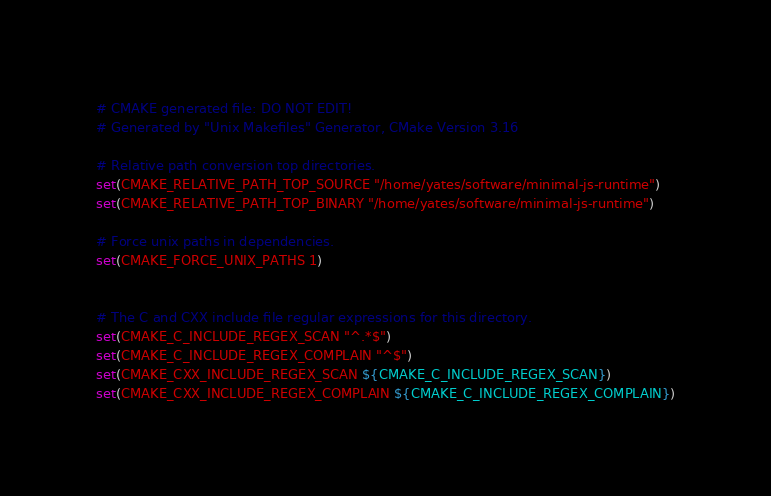<code> <loc_0><loc_0><loc_500><loc_500><_CMake_># CMAKE generated file: DO NOT EDIT!
# Generated by "Unix Makefiles" Generator, CMake Version 3.16

# Relative path conversion top directories.
set(CMAKE_RELATIVE_PATH_TOP_SOURCE "/home/yates/software/minimal-js-runtime")
set(CMAKE_RELATIVE_PATH_TOP_BINARY "/home/yates/software/minimal-js-runtime")

# Force unix paths in dependencies.
set(CMAKE_FORCE_UNIX_PATHS 1)


# The C and CXX include file regular expressions for this directory.
set(CMAKE_C_INCLUDE_REGEX_SCAN "^.*$")
set(CMAKE_C_INCLUDE_REGEX_COMPLAIN "^$")
set(CMAKE_CXX_INCLUDE_REGEX_SCAN ${CMAKE_C_INCLUDE_REGEX_SCAN})
set(CMAKE_CXX_INCLUDE_REGEX_COMPLAIN ${CMAKE_C_INCLUDE_REGEX_COMPLAIN})
</code> 